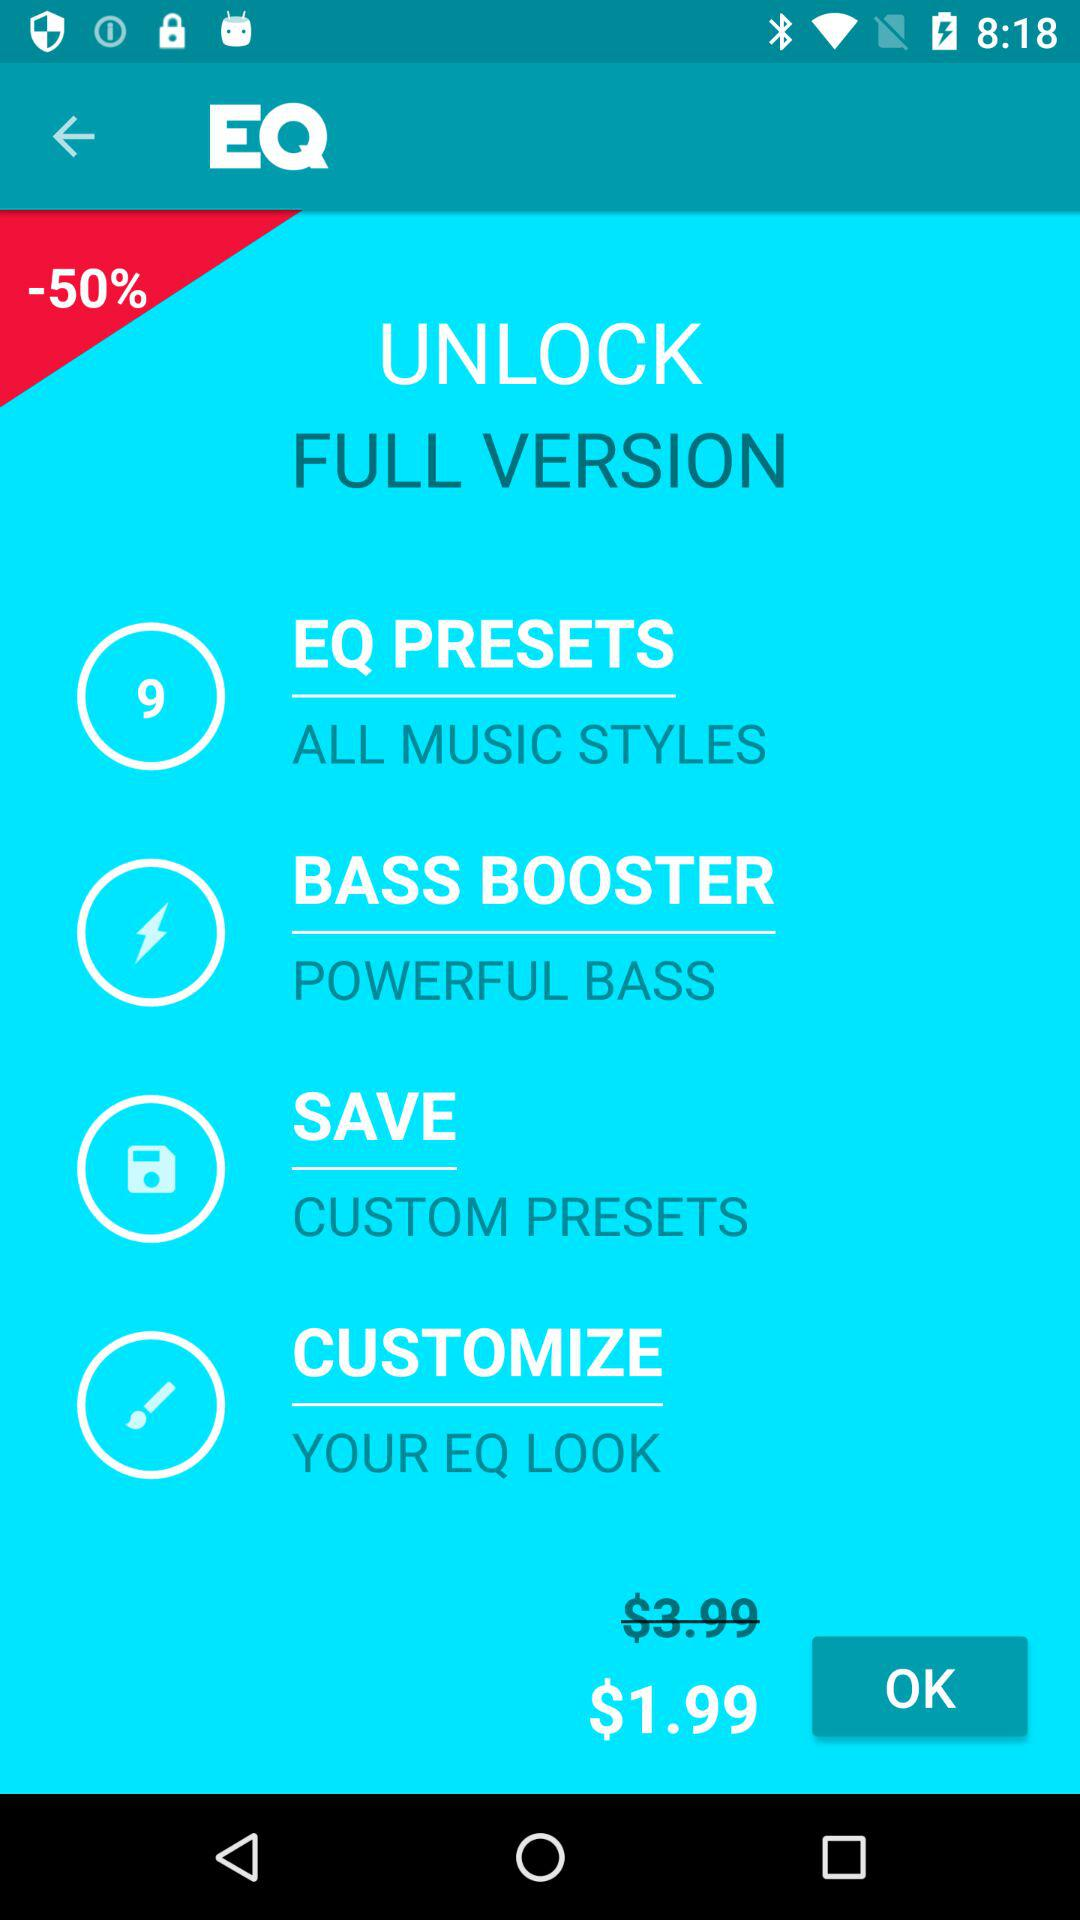What is the name of the application? The name of the application is "EQ". 